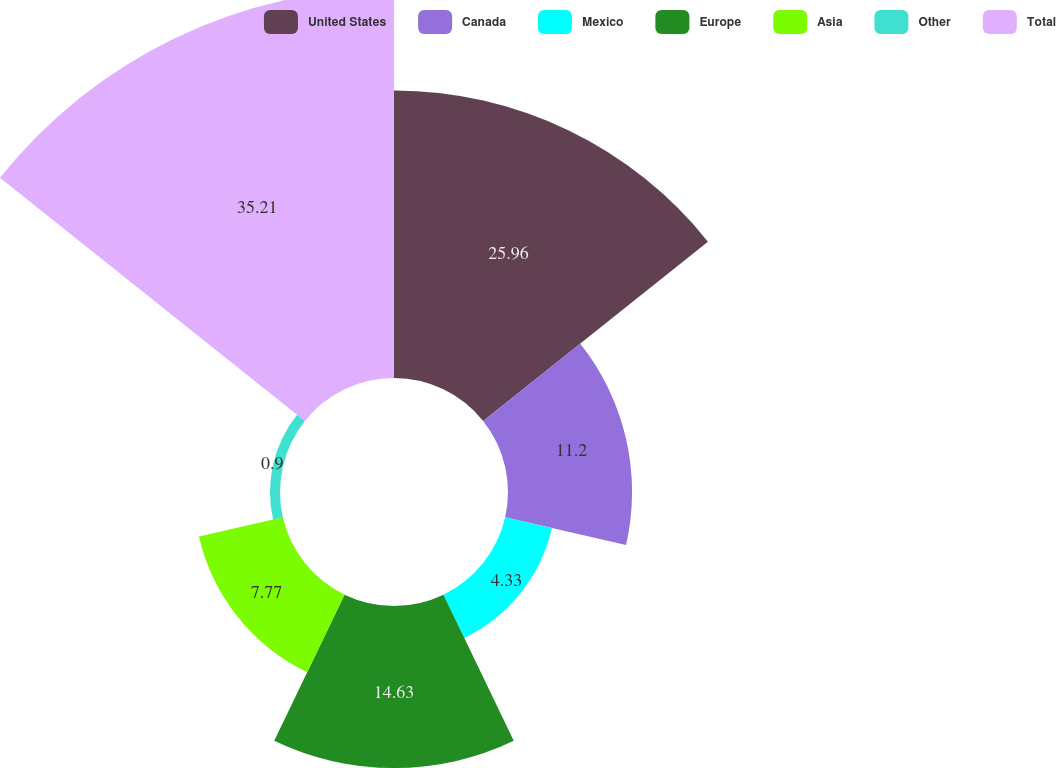Convert chart to OTSL. <chart><loc_0><loc_0><loc_500><loc_500><pie_chart><fcel>United States<fcel>Canada<fcel>Mexico<fcel>Europe<fcel>Asia<fcel>Other<fcel>Total<nl><fcel>25.96%<fcel>11.2%<fcel>4.33%<fcel>14.63%<fcel>7.77%<fcel>0.9%<fcel>35.21%<nl></chart> 